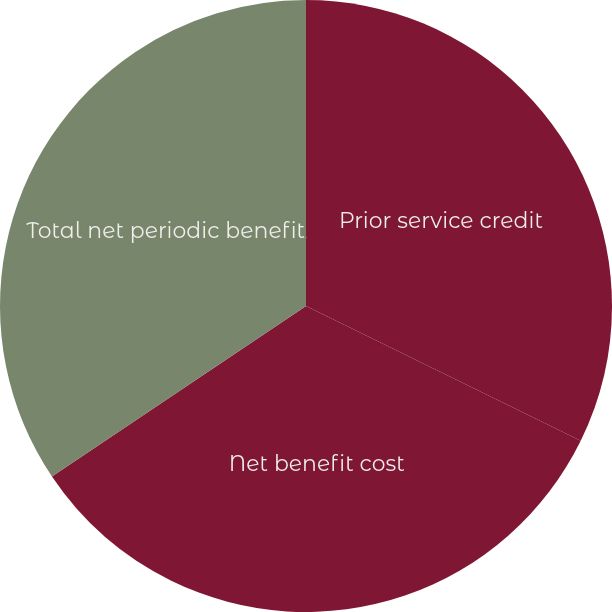Convert chart. <chart><loc_0><loc_0><loc_500><loc_500><pie_chart><fcel>Prior service credit<fcel>Net benefit cost<fcel>Total net periodic benefit<nl><fcel>32.26%<fcel>33.33%<fcel>34.41%<nl></chart> 